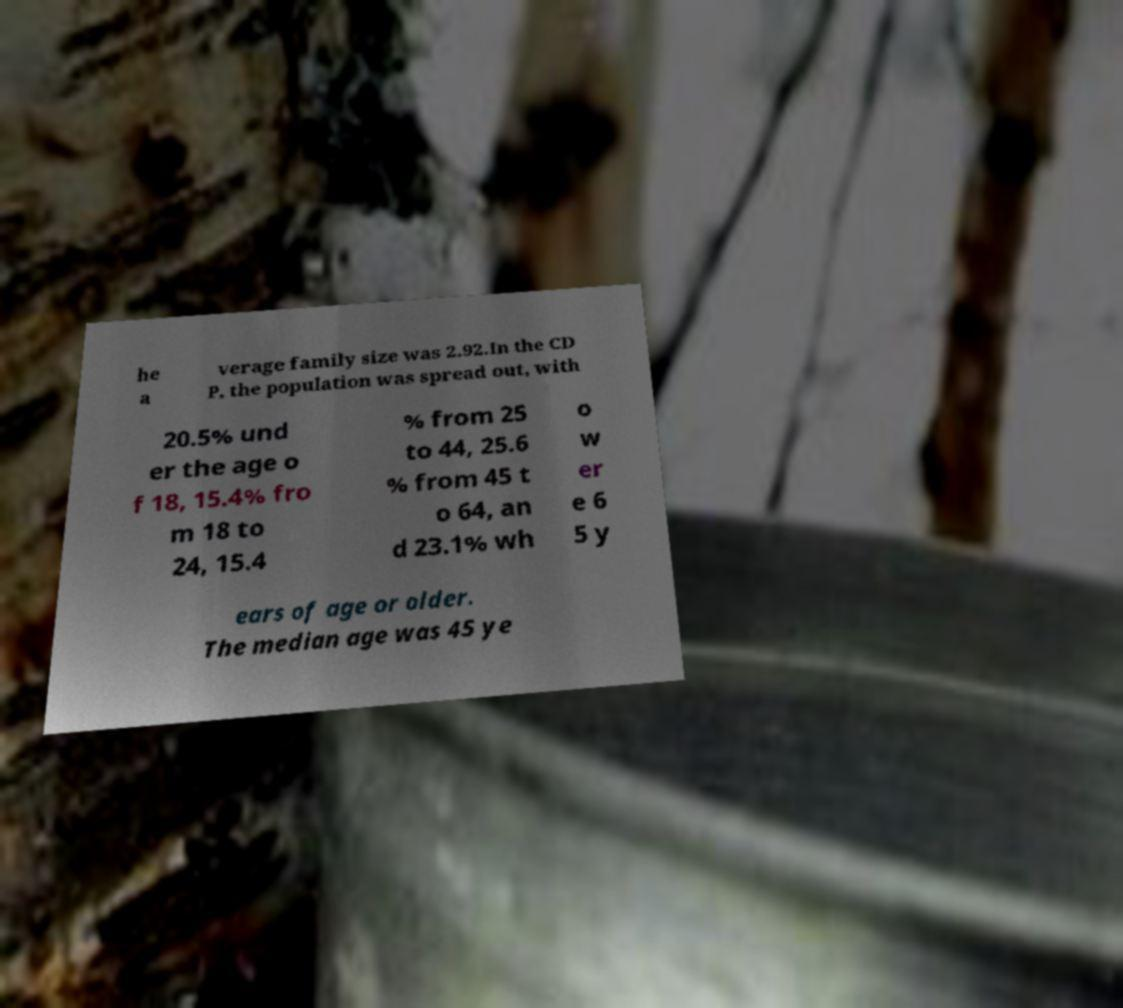There's text embedded in this image that I need extracted. Can you transcribe it verbatim? he a verage family size was 2.92.In the CD P, the population was spread out, with 20.5% und er the age o f 18, 15.4% fro m 18 to 24, 15.4 % from 25 to 44, 25.6 % from 45 t o 64, an d 23.1% wh o w er e 6 5 y ears of age or older. The median age was 45 ye 